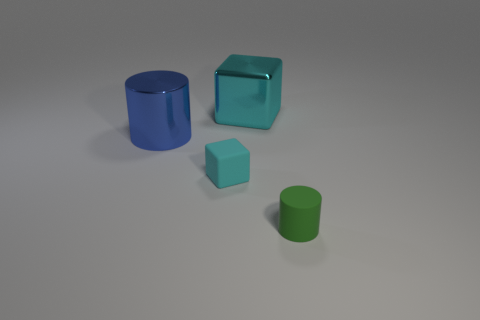Subtract 1 cubes. How many cubes are left? 1 Add 4 large blue things. How many objects exist? 8 Subtract all gray cylinders. Subtract all cyan cubes. How many cylinders are left? 2 Subtract all red spheres. How many blue cylinders are left? 1 Subtract all metallic cubes. Subtract all rubber objects. How many objects are left? 1 Add 1 big cyan metallic blocks. How many big cyan metallic blocks are left? 2 Add 4 big brown shiny objects. How many big brown shiny objects exist? 4 Subtract 0 blue balls. How many objects are left? 4 